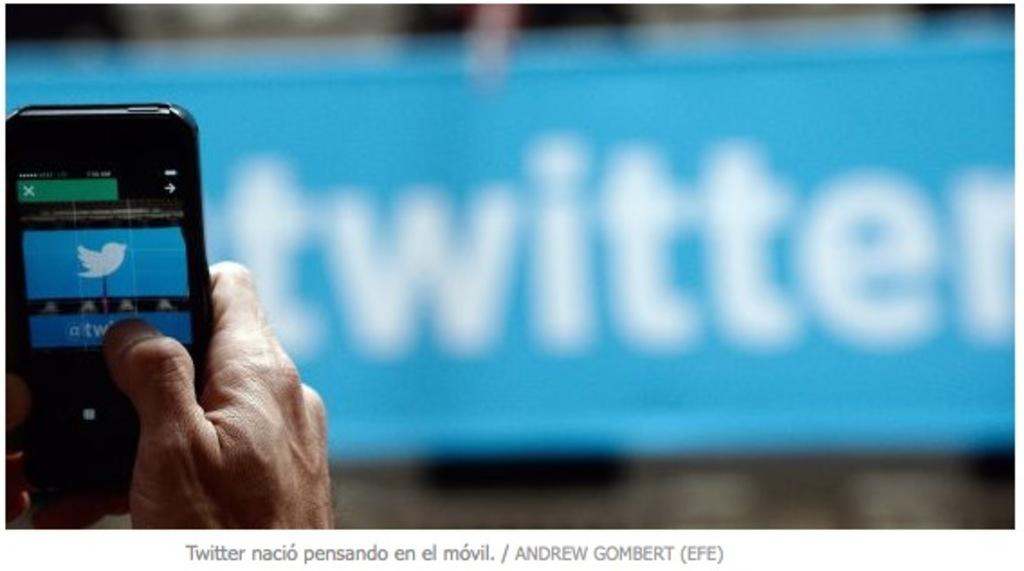<image>
Summarize the visual content of the image. A person holds up a phone in front of a sign for Twitter. 